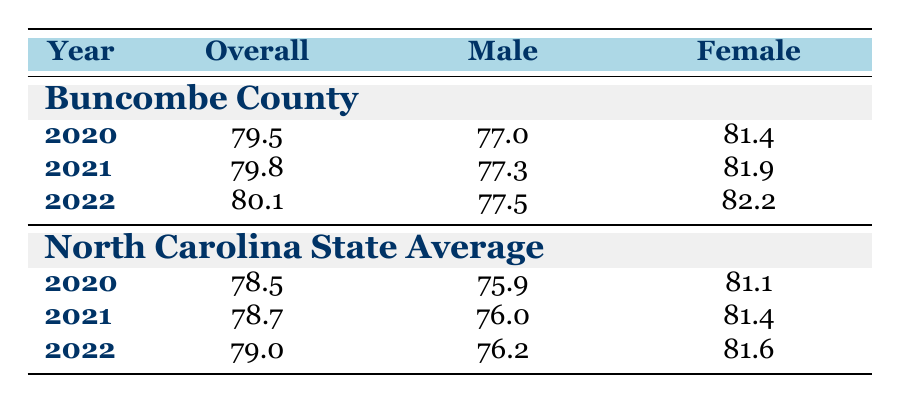What was the life expectancy in Buncombe County in 2020? The table shows that the overall life expectancy in Buncombe County for the year 2020 was listed as 79.5 years.
Answer: 79.5 What was the male life expectancy in North Carolina in 2021? According to the table, the male life expectancy for North Carolina in 2021 was 76.0 years.
Answer: 76.0 Which year had the highest female life expectancy in Buncombe County? To determine this, we check the female life expectancy figures for Buncombe County: 81.4 in 2020, 81.9 in 2021, and 82.2 in 2022. The highest figure is 82.2 in 2022.
Answer: 2022 By how many years did overall life expectancy in Buncombe County increase from 2020 to 2022? The overall life expectancy in Buncombe County increased from 79.5 in 2020 to 80.1 in 2022. To find the difference, we subtract: 80.1 - 79.5 = 0.6.
Answer: 0.6 Is the life expectancy in Buncombe County greater than the North Carolina state average for all years listed? Checking the life expectancies, Buncombe County: 79.5, 79.8, and 80.1; North Carolina: 78.5, 78.7, and 79.0. In all cases, Buncombe County has a higher life expectancy than the state averages. Therefore, the answer is yes.
Answer: Yes What was the difference between female life expectancy in Buncombe County and North Carolina in 2021? In 2021, female life expectancy in Buncombe County was 81.9 and in North Carolina, it was 81.4. The difference is 81.9 - 81.4 = 0.5 years.
Answer: 0.5 Did male life expectancy in Buncombe County ever fall below 77 years from 2020 to 2022? The male life expectancy for Buncombe County in 2020 was 77.0, in 2021 was 77.3, and in 2022 was 77.5. None of these values fall below 77 years. Therefore, the answer is no.
Answer: No What was the average life expectancy for North Carolina from 2020 to 2022? We calculate the average by summing the life expectancies for North Carolina over the three years: (78.5 + 78.7 + 79.0) / 3 = 78.733... which equals approximately 78.7 when rounded.
Answer: 78.7 